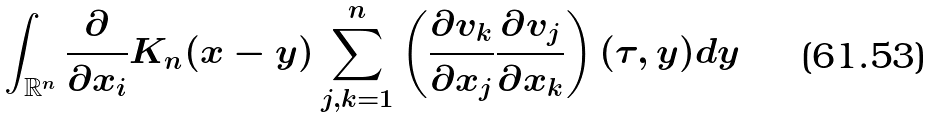<formula> <loc_0><loc_0><loc_500><loc_500>\int _ { { \mathbb { R } } ^ { n } } \frac { \partial } { \partial x _ { i } } K _ { n } ( x - y ) \sum _ { j , k = 1 } ^ { n } \left ( \frac { \partial v _ { k } } { \partial x _ { j } } \frac { \partial v _ { j } } { \partial x _ { k } } \right ) ( \tau , y ) d y</formula> 